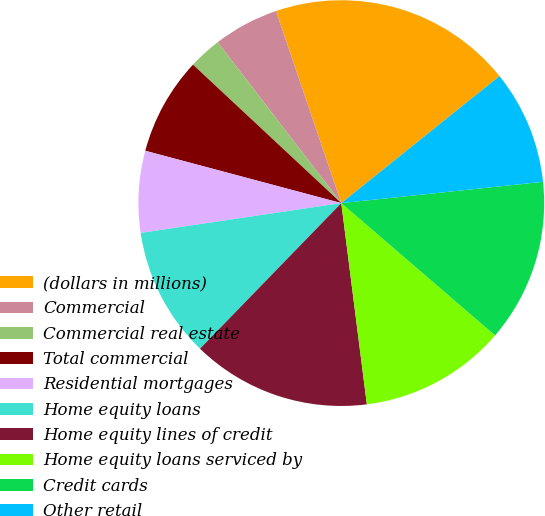Convert chart. <chart><loc_0><loc_0><loc_500><loc_500><pie_chart><fcel>(dollars in millions)<fcel>Commercial<fcel>Commercial real estate<fcel>Total commercial<fcel>Residential mortgages<fcel>Home equity loans<fcel>Home equity lines of credit<fcel>Home equity loans serviced by<fcel>Credit cards<fcel>Other retail<nl><fcel>19.45%<fcel>5.21%<fcel>2.62%<fcel>7.8%<fcel>6.5%<fcel>10.39%<fcel>14.27%<fcel>11.68%<fcel>12.98%<fcel>9.09%<nl></chart> 